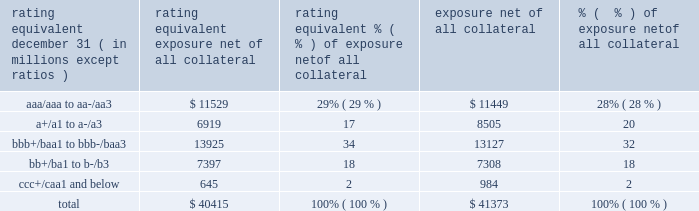Jpmorgan chase & co./2017 annual report 115 impact of wrong-way risk , which is broadly defined as the potential for increased correlation between the firm 2019s exposure to a counterparty ( avg ) and the counterparty 2019s credit quality .
Many factors may influence the nature and magnitude of these correlations over time .
To the extent that these correlations are identified , the firm may adjust the cva associated with that counterparty 2019s avg .
The firm risk manages exposure to changes in cva by entering into credit derivative transactions , as well as interest rate , foreign exchange , equity and commodity derivative transactions .
The accompanying graph shows exposure profiles to the firm 2019s current derivatives portfolio over the next 10 years as calculated by the peak , dre and avg metrics .
The three measures generally show that exposure will decline after the first year , if no new trades are added to the portfolio .
Exposure profile of derivatives measures december 31 , 2017 ( in billions ) the table summarizes the ratings profile by derivative counterparty of the firm 2019s derivative receivables , including credit derivatives , net of all collateral , at the dates indicated .
The ratings scale is based on the firm 2019s internal ratings , which generally correspond to the ratings as assigned by s&p and moody 2019s .
Ratings profile of derivative receivables .
As previously noted , the firm uses collateral agreements to mitigate counterparty credit risk .
The percentage of the firm 2019s over-the-counter derivatives transactions subject to collateral agreements 2014 excluding foreign exchange spot trades , which are not typically covered by collateral agreements due to their short maturity and centrally cleared trades that are settled daily 2014 was approximately 90% ( 90 % ) as of december 31 , 2017 , largely unchanged compared with december 31 , 2016 .
Credit derivatives the firm uses credit derivatives for two primary purposes : first , in its capacity as a market-maker , and second , as an end-user to manage the firm 2019s own credit risk associated with various exposures .
For a detailed description of credit derivatives , see credit derivatives in note 5 .
Credit portfolio management activities included in the firm 2019s end-user activities are credit derivatives used to mitigate the credit risk associated with traditional lending activities ( loans and unfunded commitments ) and derivatives counterparty exposure in the firm 2019s wholesale businesses ( collectively , 201ccredit portfolio management 201d activities ) .
Information on credit portfolio management activities is provided in the table below .
For further information on derivatives used in credit portfolio management activities , see credit derivatives in note 5 .
The firm also uses credit derivatives as an end-user to manage other exposures , including credit risk arising from certain securities held in the firm 2019s market-making businesses .
These credit derivatives are not included in credit portfolio management activities ; for further information on these credit derivatives as well as credit derivatives used in the firm 2019s capacity as a market-maker in credit derivatives , see credit derivatives in note 5 .
10 years5 years2 years1 year .
For 2017 , what percentage of derivative receivables are rated junk? 
Rationale: junk = below bbb+/baa1 to bbb-/baa3
Computations: (18 + 2)
Answer: 20.0. 